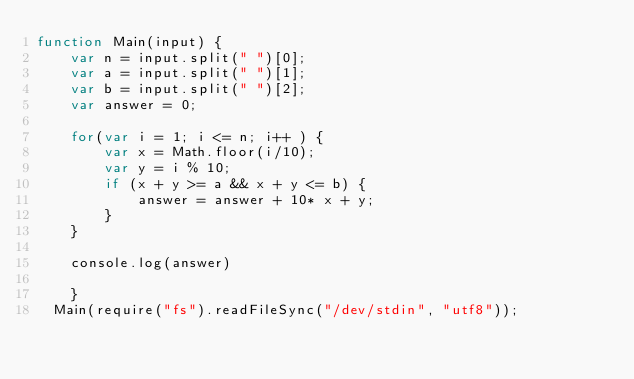Convert code to text. <code><loc_0><loc_0><loc_500><loc_500><_JavaScript_>function Main(input) {
    var n = input.split(" ")[0];
    var a = input.split(" ")[1];
    var b = input.split(" ")[2];
    var answer = 0;

    for(var i = 1; i <= n; i++ ) {
        var x = Math.floor(i/10);
        var y = i % 10;
        if (x + y >= a && x + y <= b) {
            answer = answer + 10* x + y;
        }
    }

    console.log(answer)
  
    }
  Main(require("fs").readFileSync("/dev/stdin", "utf8"));
  </code> 